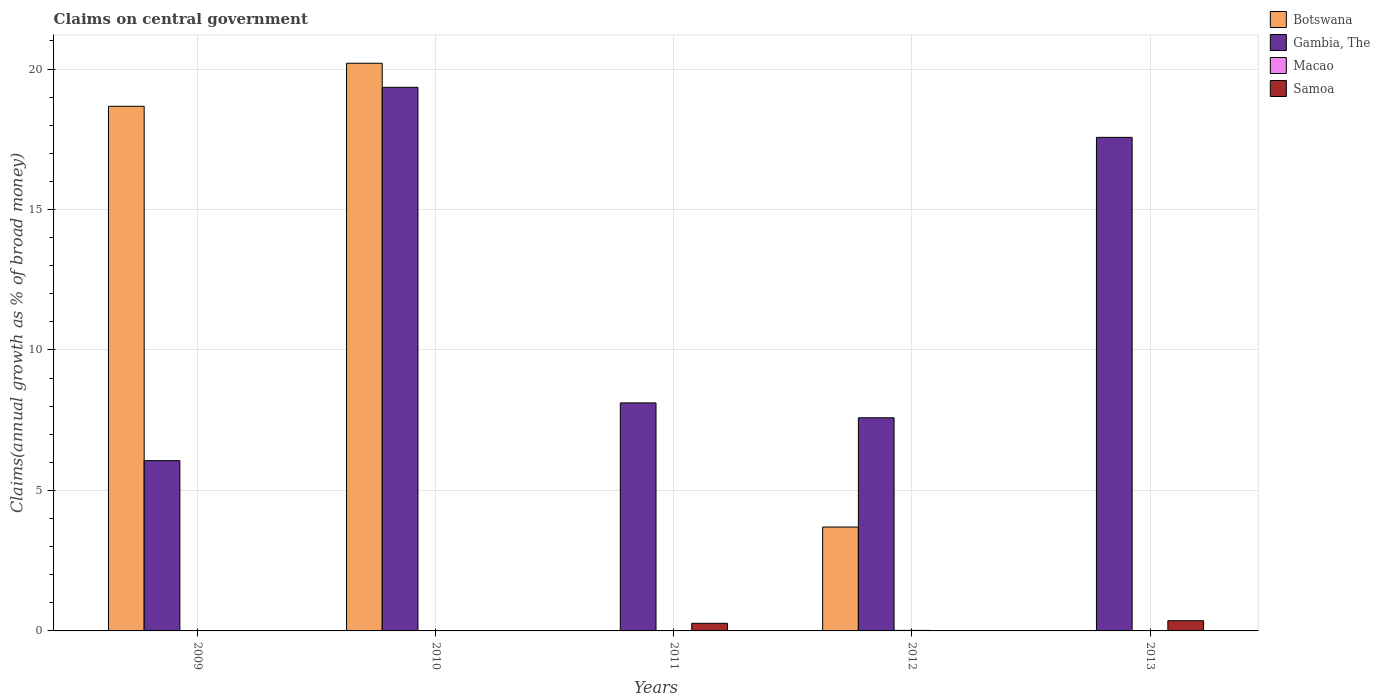How many different coloured bars are there?
Your response must be concise. 4. Are the number of bars per tick equal to the number of legend labels?
Offer a terse response. No. Are the number of bars on each tick of the X-axis equal?
Provide a succinct answer. No. In how many cases, is the number of bars for a given year not equal to the number of legend labels?
Your response must be concise. 5. What is the percentage of broad money claimed on centeral government in Gambia, The in 2010?
Make the answer very short. 19.35. Across all years, what is the maximum percentage of broad money claimed on centeral government in Gambia, The?
Keep it short and to the point. 19.35. What is the total percentage of broad money claimed on centeral government in Gambia, The in the graph?
Ensure brevity in your answer.  58.68. What is the difference between the percentage of broad money claimed on centeral government in Gambia, The in 2009 and that in 2012?
Make the answer very short. -1.53. What is the difference between the percentage of broad money claimed on centeral government in Macao in 2011 and the percentage of broad money claimed on centeral government in Gambia, The in 2009?
Provide a short and direct response. -6.06. What is the average percentage of broad money claimed on centeral government in Samoa per year?
Make the answer very short. 0.13. In the year 2009, what is the difference between the percentage of broad money claimed on centeral government in Gambia, The and percentage of broad money claimed on centeral government in Botswana?
Keep it short and to the point. -12.61. What is the ratio of the percentage of broad money claimed on centeral government in Gambia, The in 2011 to that in 2012?
Your answer should be compact. 1.07. Is the percentage of broad money claimed on centeral government in Gambia, The in 2011 less than that in 2012?
Keep it short and to the point. No. What is the difference between the highest and the second highest percentage of broad money claimed on centeral government in Gambia, The?
Give a very brief answer. 1.78. What is the difference between the highest and the lowest percentage of broad money claimed on centeral government in Gambia, The?
Offer a very short reply. 13.29. In how many years, is the percentage of broad money claimed on centeral government in Gambia, The greater than the average percentage of broad money claimed on centeral government in Gambia, The taken over all years?
Your answer should be very brief. 2. Is the sum of the percentage of broad money claimed on centeral government in Gambia, The in 2012 and 2013 greater than the maximum percentage of broad money claimed on centeral government in Samoa across all years?
Your answer should be very brief. Yes. Is it the case that in every year, the sum of the percentage of broad money claimed on centeral government in Botswana and percentage of broad money claimed on centeral government in Macao is greater than the sum of percentage of broad money claimed on centeral government in Samoa and percentage of broad money claimed on centeral government in Gambia, The?
Provide a short and direct response. No. Is it the case that in every year, the sum of the percentage of broad money claimed on centeral government in Gambia, The and percentage of broad money claimed on centeral government in Macao is greater than the percentage of broad money claimed on centeral government in Botswana?
Ensure brevity in your answer.  No. How many years are there in the graph?
Offer a very short reply. 5. What is the difference between two consecutive major ticks on the Y-axis?
Provide a succinct answer. 5. Does the graph contain any zero values?
Make the answer very short. Yes. Does the graph contain grids?
Provide a short and direct response. Yes. How are the legend labels stacked?
Make the answer very short. Vertical. What is the title of the graph?
Offer a very short reply. Claims on central government. What is the label or title of the Y-axis?
Your answer should be compact. Claims(annual growth as % of broad money). What is the Claims(annual growth as % of broad money) in Botswana in 2009?
Provide a succinct answer. 18.68. What is the Claims(annual growth as % of broad money) in Gambia, The in 2009?
Make the answer very short. 6.06. What is the Claims(annual growth as % of broad money) in Macao in 2009?
Ensure brevity in your answer.  0. What is the Claims(annual growth as % of broad money) in Samoa in 2009?
Offer a very short reply. 0. What is the Claims(annual growth as % of broad money) of Botswana in 2010?
Your response must be concise. 20.21. What is the Claims(annual growth as % of broad money) in Gambia, The in 2010?
Make the answer very short. 19.35. What is the Claims(annual growth as % of broad money) of Gambia, The in 2011?
Your response must be concise. 8.12. What is the Claims(annual growth as % of broad money) in Macao in 2011?
Make the answer very short. 0. What is the Claims(annual growth as % of broad money) in Samoa in 2011?
Keep it short and to the point. 0.27. What is the Claims(annual growth as % of broad money) of Botswana in 2012?
Keep it short and to the point. 3.7. What is the Claims(annual growth as % of broad money) in Gambia, The in 2012?
Your answer should be compact. 7.59. What is the Claims(annual growth as % of broad money) of Macao in 2012?
Keep it short and to the point. 0.02. What is the Claims(annual growth as % of broad money) in Samoa in 2012?
Keep it short and to the point. 0. What is the Claims(annual growth as % of broad money) of Gambia, The in 2013?
Provide a succinct answer. 17.57. What is the Claims(annual growth as % of broad money) in Macao in 2013?
Make the answer very short. 0. What is the Claims(annual growth as % of broad money) in Samoa in 2013?
Make the answer very short. 0.36. Across all years, what is the maximum Claims(annual growth as % of broad money) in Botswana?
Ensure brevity in your answer.  20.21. Across all years, what is the maximum Claims(annual growth as % of broad money) in Gambia, The?
Offer a very short reply. 19.35. Across all years, what is the maximum Claims(annual growth as % of broad money) in Macao?
Your answer should be very brief. 0.02. Across all years, what is the maximum Claims(annual growth as % of broad money) in Samoa?
Ensure brevity in your answer.  0.36. Across all years, what is the minimum Claims(annual growth as % of broad money) in Gambia, The?
Ensure brevity in your answer.  6.06. Across all years, what is the minimum Claims(annual growth as % of broad money) of Samoa?
Give a very brief answer. 0. What is the total Claims(annual growth as % of broad money) in Botswana in the graph?
Keep it short and to the point. 42.58. What is the total Claims(annual growth as % of broad money) of Gambia, The in the graph?
Your answer should be compact. 58.68. What is the total Claims(annual growth as % of broad money) of Macao in the graph?
Give a very brief answer. 0.02. What is the total Claims(annual growth as % of broad money) in Samoa in the graph?
Keep it short and to the point. 0.64. What is the difference between the Claims(annual growth as % of broad money) in Botswana in 2009 and that in 2010?
Offer a terse response. -1.53. What is the difference between the Claims(annual growth as % of broad money) in Gambia, The in 2009 and that in 2010?
Offer a terse response. -13.29. What is the difference between the Claims(annual growth as % of broad money) in Gambia, The in 2009 and that in 2011?
Keep it short and to the point. -2.06. What is the difference between the Claims(annual growth as % of broad money) of Botswana in 2009 and that in 2012?
Offer a terse response. 14.98. What is the difference between the Claims(annual growth as % of broad money) in Gambia, The in 2009 and that in 2012?
Keep it short and to the point. -1.53. What is the difference between the Claims(annual growth as % of broad money) of Gambia, The in 2009 and that in 2013?
Offer a very short reply. -11.51. What is the difference between the Claims(annual growth as % of broad money) in Gambia, The in 2010 and that in 2011?
Provide a succinct answer. 11.23. What is the difference between the Claims(annual growth as % of broad money) of Botswana in 2010 and that in 2012?
Provide a short and direct response. 16.51. What is the difference between the Claims(annual growth as % of broad money) of Gambia, The in 2010 and that in 2012?
Keep it short and to the point. 11.76. What is the difference between the Claims(annual growth as % of broad money) of Gambia, The in 2010 and that in 2013?
Keep it short and to the point. 1.78. What is the difference between the Claims(annual growth as % of broad money) in Gambia, The in 2011 and that in 2012?
Your answer should be compact. 0.53. What is the difference between the Claims(annual growth as % of broad money) of Gambia, The in 2011 and that in 2013?
Provide a succinct answer. -9.45. What is the difference between the Claims(annual growth as % of broad money) in Samoa in 2011 and that in 2013?
Your response must be concise. -0.09. What is the difference between the Claims(annual growth as % of broad money) of Gambia, The in 2012 and that in 2013?
Provide a short and direct response. -9.98. What is the difference between the Claims(annual growth as % of broad money) of Botswana in 2009 and the Claims(annual growth as % of broad money) of Gambia, The in 2010?
Offer a very short reply. -0.67. What is the difference between the Claims(annual growth as % of broad money) of Botswana in 2009 and the Claims(annual growth as % of broad money) of Gambia, The in 2011?
Keep it short and to the point. 10.56. What is the difference between the Claims(annual growth as % of broad money) in Botswana in 2009 and the Claims(annual growth as % of broad money) in Samoa in 2011?
Ensure brevity in your answer.  18.4. What is the difference between the Claims(annual growth as % of broad money) of Gambia, The in 2009 and the Claims(annual growth as % of broad money) of Samoa in 2011?
Provide a short and direct response. 5.79. What is the difference between the Claims(annual growth as % of broad money) in Botswana in 2009 and the Claims(annual growth as % of broad money) in Gambia, The in 2012?
Give a very brief answer. 11.09. What is the difference between the Claims(annual growth as % of broad money) of Botswana in 2009 and the Claims(annual growth as % of broad money) of Macao in 2012?
Keep it short and to the point. 18.66. What is the difference between the Claims(annual growth as % of broad money) in Gambia, The in 2009 and the Claims(annual growth as % of broad money) in Macao in 2012?
Provide a succinct answer. 6.04. What is the difference between the Claims(annual growth as % of broad money) in Botswana in 2009 and the Claims(annual growth as % of broad money) in Gambia, The in 2013?
Offer a very short reply. 1.11. What is the difference between the Claims(annual growth as % of broad money) of Botswana in 2009 and the Claims(annual growth as % of broad money) of Samoa in 2013?
Your response must be concise. 18.31. What is the difference between the Claims(annual growth as % of broad money) of Gambia, The in 2009 and the Claims(annual growth as % of broad money) of Samoa in 2013?
Offer a very short reply. 5.7. What is the difference between the Claims(annual growth as % of broad money) of Botswana in 2010 and the Claims(annual growth as % of broad money) of Gambia, The in 2011?
Ensure brevity in your answer.  12.09. What is the difference between the Claims(annual growth as % of broad money) in Botswana in 2010 and the Claims(annual growth as % of broad money) in Samoa in 2011?
Provide a succinct answer. 19.93. What is the difference between the Claims(annual growth as % of broad money) in Gambia, The in 2010 and the Claims(annual growth as % of broad money) in Samoa in 2011?
Offer a very short reply. 19.08. What is the difference between the Claims(annual growth as % of broad money) in Botswana in 2010 and the Claims(annual growth as % of broad money) in Gambia, The in 2012?
Keep it short and to the point. 12.62. What is the difference between the Claims(annual growth as % of broad money) of Botswana in 2010 and the Claims(annual growth as % of broad money) of Macao in 2012?
Provide a short and direct response. 20.19. What is the difference between the Claims(annual growth as % of broad money) in Gambia, The in 2010 and the Claims(annual growth as % of broad money) in Macao in 2012?
Give a very brief answer. 19.33. What is the difference between the Claims(annual growth as % of broad money) in Botswana in 2010 and the Claims(annual growth as % of broad money) in Gambia, The in 2013?
Your response must be concise. 2.64. What is the difference between the Claims(annual growth as % of broad money) in Botswana in 2010 and the Claims(annual growth as % of broad money) in Samoa in 2013?
Give a very brief answer. 19.84. What is the difference between the Claims(annual growth as % of broad money) in Gambia, The in 2010 and the Claims(annual growth as % of broad money) in Samoa in 2013?
Offer a very short reply. 18.99. What is the difference between the Claims(annual growth as % of broad money) of Gambia, The in 2011 and the Claims(annual growth as % of broad money) of Macao in 2012?
Your response must be concise. 8.1. What is the difference between the Claims(annual growth as % of broad money) of Gambia, The in 2011 and the Claims(annual growth as % of broad money) of Samoa in 2013?
Your answer should be very brief. 7.75. What is the difference between the Claims(annual growth as % of broad money) of Botswana in 2012 and the Claims(annual growth as % of broad money) of Gambia, The in 2013?
Offer a terse response. -13.87. What is the difference between the Claims(annual growth as % of broad money) in Botswana in 2012 and the Claims(annual growth as % of broad money) in Samoa in 2013?
Keep it short and to the point. 3.33. What is the difference between the Claims(annual growth as % of broad money) of Gambia, The in 2012 and the Claims(annual growth as % of broad money) of Samoa in 2013?
Your response must be concise. 7.22. What is the difference between the Claims(annual growth as % of broad money) in Macao in 2012 and the Claims(annual growth as % of broad money) in Samoa in 2013?
Provide a succinct answer. -0.34. What is the average Claims(annual growth as % of broad money) in Botswana per year?
Ensure brevity in your answer.  8.52. What is the average Claims(annual growth as % of broad money) in Gambia, The per year?
Offer a very short reply. 11.74. What is the average Claims(annual growth as % of broad money) in Macao per year?
Your answer should be compact. 0. What is the average Claims(annual growth as % of broad money) in Samoa per year?
Offer a very short reply. 0.13. In the year 2009, what is the difference between the Claims(annual growth as % of broad money) of Botswana and Claims(annual growth as % of broad money) of Gambia, The?
Offer a terse response. 12.61. In the year 2010, what is the difference between the Claims(annual growth as % of broad money) of Botswana and Claims(annual growth as % of broad money) of Gambia, The?
Provide a short and direct response. 0.86. In the year 2011, what is the difference between the Claims(annual growth as % of broad money) of Gambia, The and Claims(annual growth as % of broad money) of Samoa?
Make the answer very short. 7.85. In the year 2012, what is the difference between the Claims(annual growth as % of broad money) in Botswana and Claims(annual growth as % of broad money) in Gambia, The?
Offer a terse response. -3.89. In the year 2012, what is the difference between the Claims(annual growth as % of broad money) in Botswana and Claims(annual growth as % of broad money) in Macao?
Offer a very short reply. 3.68. In the year 2012, what is the difference between the Claims(annual growth as % of broad money) of Gambia, The and Claims(annual growth as % of broad money) of Macao?
Your answer should be very brief. 7.57. In the year 2013, what is the difference between the Claims(annual growth as % of broad money) in Gambia, The and Claims(annual growth as % of broad money) in Samoa?
Provide a short and direct response. 17.21. What is the ratio of the Claims(annual growth as % of broad money) in Botswana in 2009 to that in 2010?
Give a very brief answer. 0.92. What is the ratio of the Claims(annual growth as % of broad money) in Gambia, The in 2009 to that in 2010?
Offer a very short reply. 0.31. What is the ratio of the Claims(annual growth as % of broad money) of Gambia, The in 2009 to that in 2011?
Your answer should be very brief. 0.75. What is the ratio of the Claims(annual growth as % of broad money) of Botswana in 2009 to that in 2012?
Offer a terse response. 5.05. What is the ratio of the Claims(annual growth as % of broad money) in Gambia, The in 2009 to that in 2012?
Offer a very short reply. 0.8. What is the ratio of the Claims(annual growth as % of broad money) of Gambia, The in 2009 to that in 2013?
Provide a succinct answer. 0.34. What is the ratio of the Claims(annual growth as % of broad money) of Gambia, The in 2010 to that in 2011?
Provide a short and direct response. 2.38. What is the ratio of the Claims(annual growth as % of broad money) of Botswana in 2010 to that in 2012?
Provide a short and direct response. 5.46. What is the ratio of the Claims(annual growth as % of broad money) of Gambia, The in 2010 to that in 2012?
Provide a succinct answer. 2.55. What is the ratio of the Claims(annual growth as % of broad money) of Gambia, The in 2010 to that in 2013?
Your response must be concise. 1.1. What is the ratio of the Claims(annual growth as % of broad money) in Gambia, The in 2011 to that in 2012?
Ensure brevity in your answer.  1.07. What is the ratio of the Claims(annual growth as % of broad money) of Gambia, The in 2011 to that in 2013?
Offer a terse response. 0.46. What is the ratio of the Claims(annual growth as % of broad money) of Samoa in 2011 to that in 2013?
Your answer should be compact. 0.75. What is the ratio of the Claims(annual growth as % of broad money) of Gambia, The in 2012 to that in 2013?
Ensure brevity in your answer.  0.43. What is the difference between the highest and the second highest Claims(annual growth as % of broad money) in Botswana?
Your answer should be compact. 1.53. What is the difference between the highest and the second highest Claims(annual growth as % of broad money) of Gambia, The?
Offer a very short reply. 1.78. What is the difference between the highest and the lowest Claims(annual growth as % of broad money) of Botswana?
Keep it short and to the point. 20.21. What is the difference between the highest and the lowest Claims(annual growth as % of broad money) in Gambia, The?
Make the answer very short. 13.29. What is the difference between the highest and the lowest Claims(annual growth as % of broad money) of Macao?
Your answer should be very brief. 0.02. What is the difference between the highest and the lowest Claims(annual growth as % of broad money) of Samoa?
Your response must be concise. 0.36. 